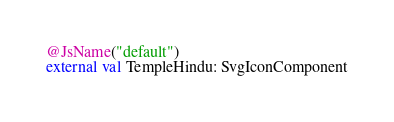<code> <loc_0><loc_0><loc_500><loc_500><_Kotlin_>@JsName("default")
external val TempleHindu: SvgIconComponent
</code> 